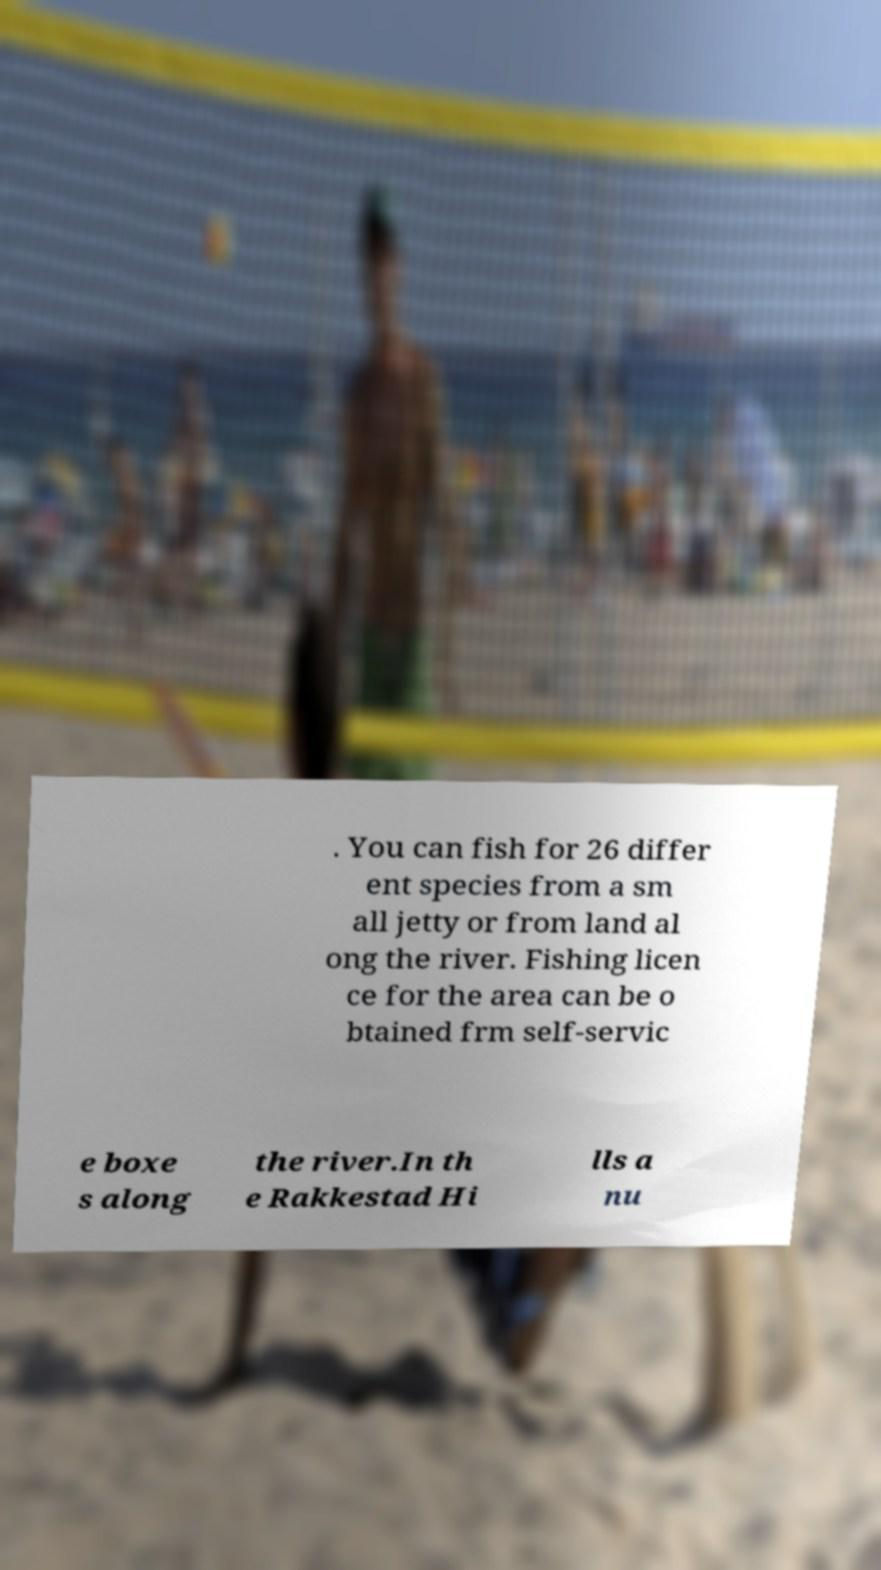Could you assist in decoding the text presented in this image and type it out clearly? . You can fish for 26 differ ent species from a sm all jetty or from land al ong the river. Fishing licen ce for the area can be o btained frm self-servic e boxe s along the river.In th e Rakkestad Hi lls a nu 